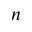<formula> <loc_0><loc_0><loc_500><loc_500>n</formula> 